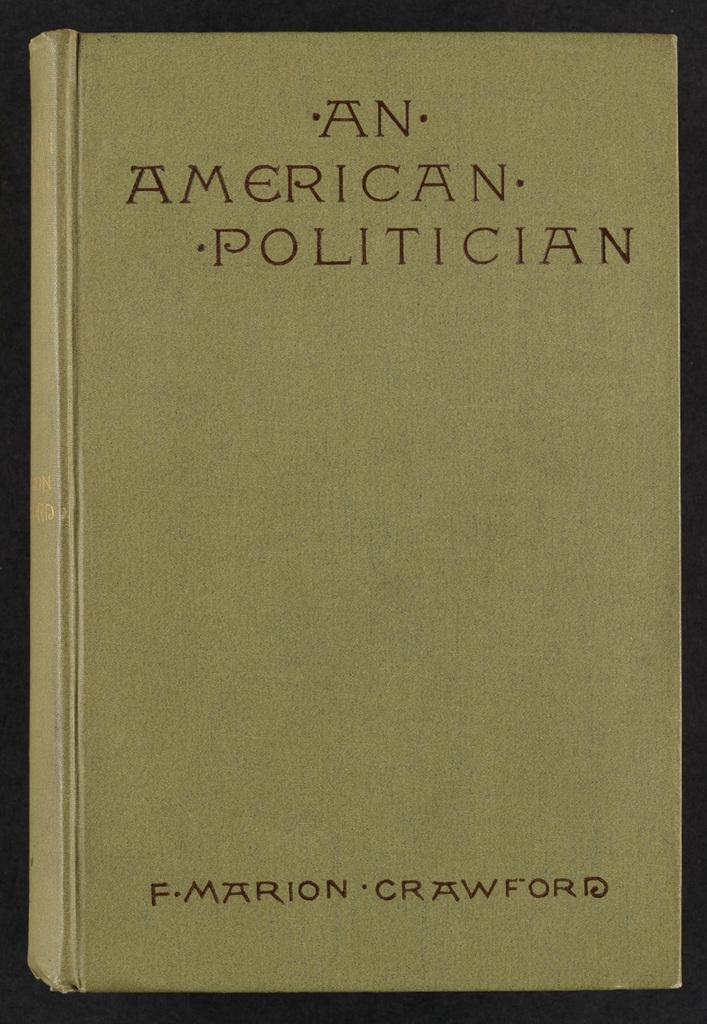<image>
Describe the image concisely. The book An American Politician was written by F. Marion Crawford. 